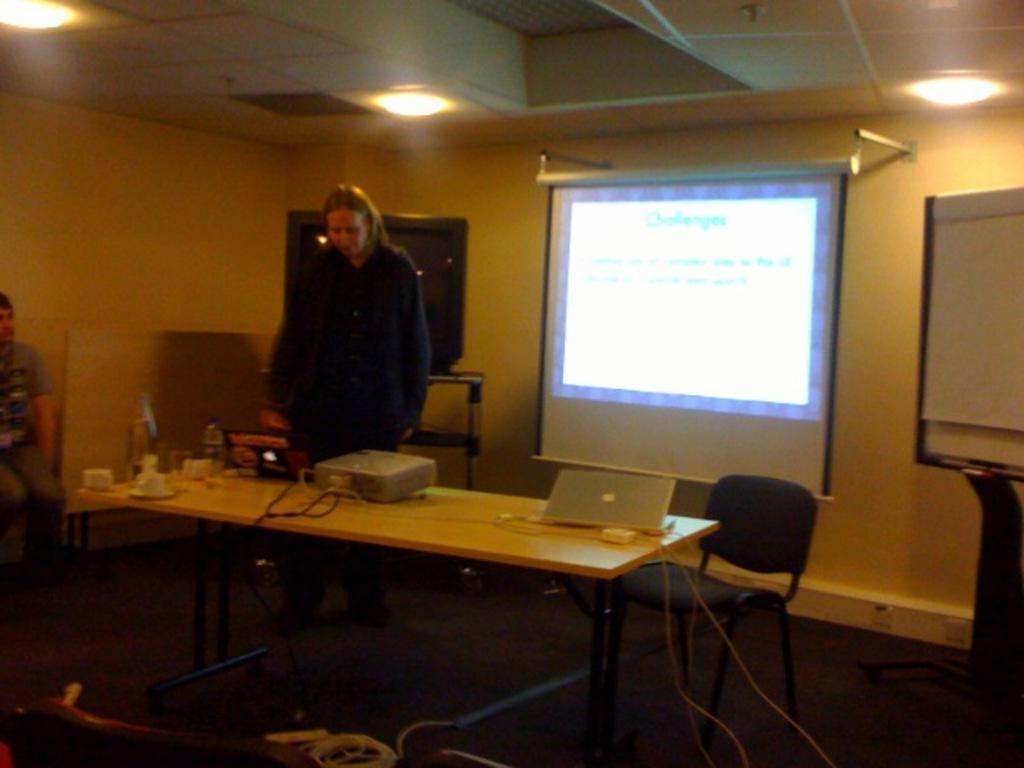Can you describe this image briefly? In this image in the center there is a table, on the table there is a laptop and bottles, there are cups and there are wires. In the center there are persons standing and sitting and there is an empty chair which is black in colour. In the background there is a TV which is black in colour and there is screen and on the top there are lights and on the right side there is object which is white in colour. On the floor there are wires and there is an empty chair in the front on the left side which is black in colour. 